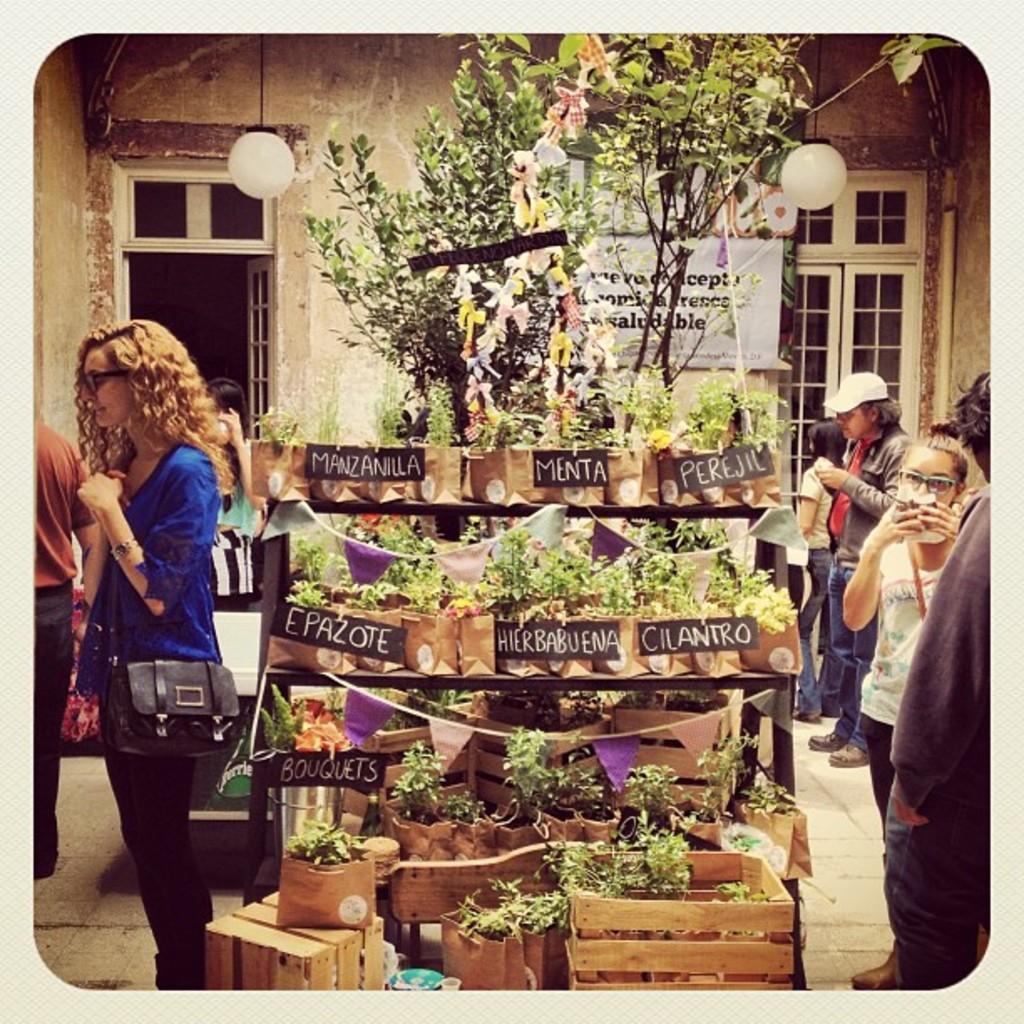How would you summarize this image in a sentence or two? In this image we can see few plants on the stand with name boards to the plants and there are trees behind the stand, there are few people standing beside the stand and there are wooden boxes in front of the stand and in the background there is a building with doors and lights on the top. 